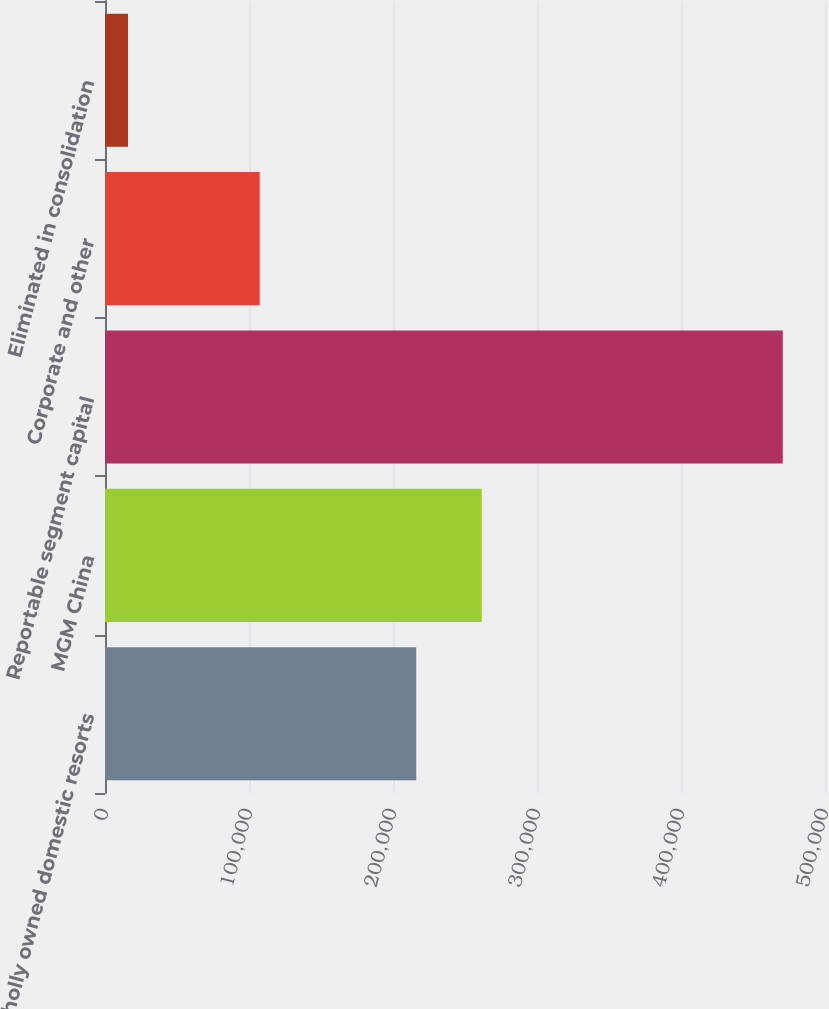Convert chart to OTSL. <chart><loc_0><loc_0><loc_500><loc_500><bar_chart><fcel>Wholly owned domestic resorts<fcel>MGM China<fcel>Reportable segment capital<fcel>Corporate and other<fcel>Eliminated in consolidation<nl><fcel>216147<fcel>261615<fcel>470663<fcel>107442<fcel>15981<nl></chart> 